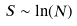Convert formula to latex. <formula><loc_0><loc_0><loc_500><loc_500>S \sim \ln ( N )</formula> 